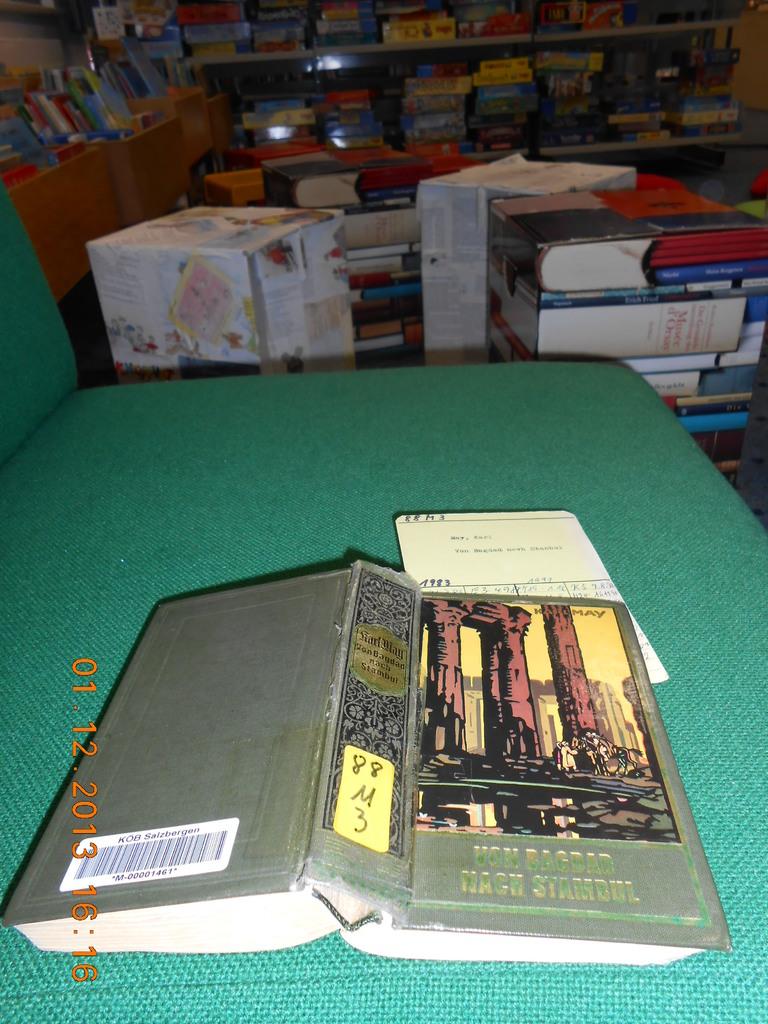What is the library code letter used for this book?
Keep it short and to the point. M. What year was the photo taken?
Provide a short and direct response. 2013. 